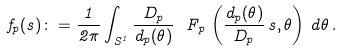Convert formula to latex. <formula><loc_0><loc_0><loc_500><loc_500>f _ { p } ( s ) \colon = \frac { 1 } { 2 \pi } \int _ { S ^ { 1 } } \frac { D _ { p } } { d _ { p } ( \theta ) } \ F _ { p } \, \left ( \frac { d _ { p } ( \theta ) } { D _ { p } } \, s , \theta \right ) \, d \theta \, .</formula> 